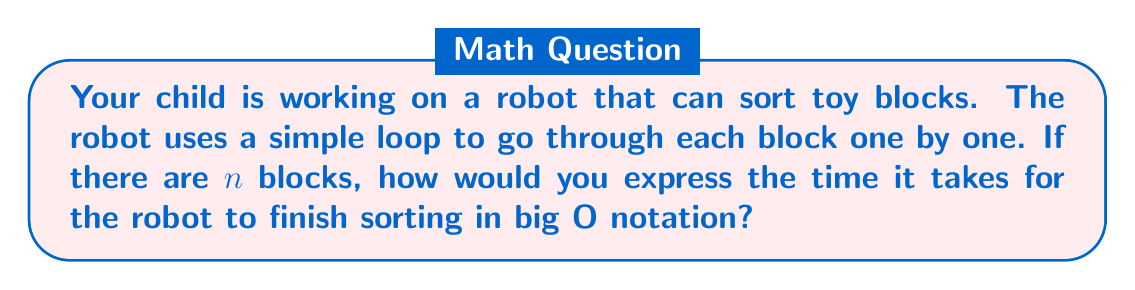Help me with this question. Let's break this down step-by-step:

1. First, we need to understand what the robot is doing. It's going through each block one at a time.

2. In big O notation, we're interested in how the time increases as the number of blocks (n) increases.

3. Since the robot looks at each block once:
   - If there's 1 block, it takes 1 step
   - If there are 2 blocks, it takes 2 steps
   - If there are 3 blocks, it takes 3 steps
   ...and so on

4. We can see that the number of steps is directly proportional to the number of blocks (n).

5. In big O notation, when the time or number of steps increases linearly with the input size, we express this as $O(n)$.

6. The $O$ stands for "order of" and the $n$ inside the parentheses represents the input size (in this case, the number of blocks).

So, the time it takes for the robot to finish sorting can be expressed as $O(n)$ in big O notation.
Answer: $O(n)$ 